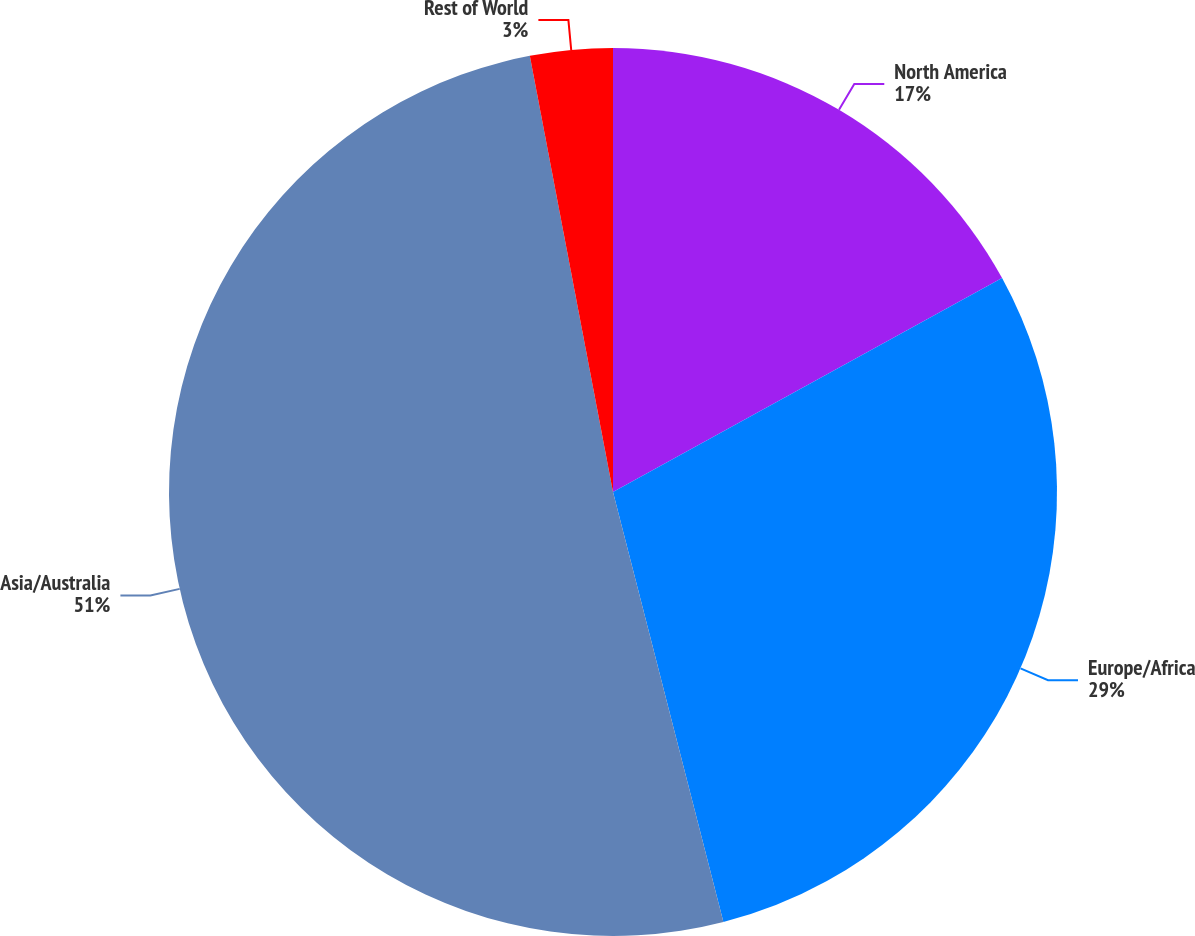Convert chart to OTSL. <chart><loc_0><loc_0><loc_500><loc_500><pie_chart><fcel>North America<fcel>Europe/Africa<fcel>Asia/Australia<fcel>Rest of World<nl><fcel>17.0%<fcel>29.0%<fcel>51.0%<fcel>3.0%<nl></chart> 